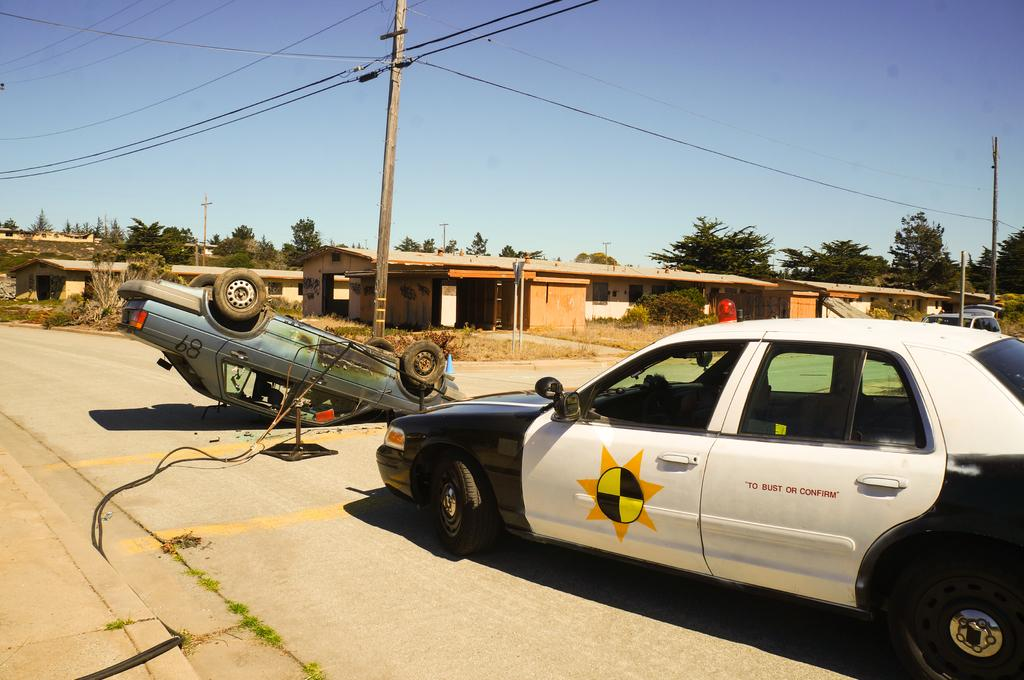<image>
Render a clear and concise summary of the photo. a police car in the road has words "to bust or confirm" on the side 